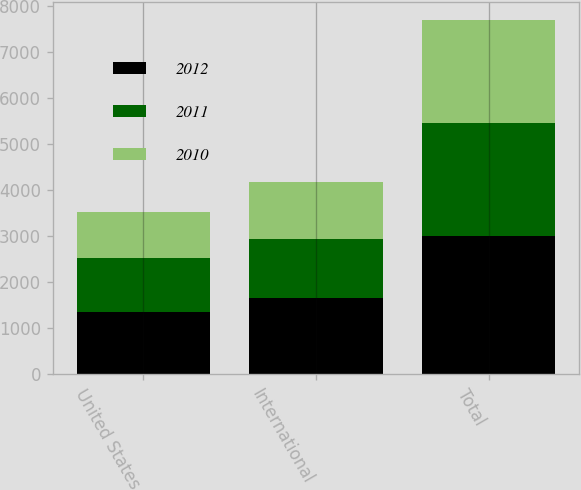Convert chart. <chart><loc_0><loc_0><loc_500><loc_500><stacked_bar_chart><ecel><fcel>United States<fcel>International<fcel>Total<nl><fcel>2012<fcel>1349.9<fcel>1660.9<fcel>3010.8<nl><fcel>2011<fcel>1168.1<fcel>1279.7<fcel>2447.8<nl><fcel>2010<fcel>1006.3<fcel>1223.3<fcel>2229.6<nl></chart> 